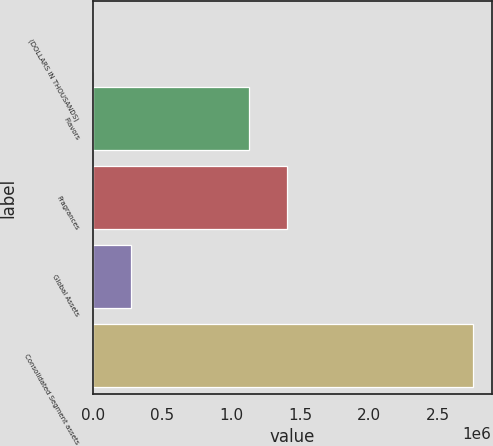Convert chart to OTSL. <chart><loc_0><loc_0><loc_500><loc_500><bar_chart><fcel>(DOLLARS IN THOUSANDS)<fcel>Flavors<fcel>Fragrances<fcel>Global Assets<fcel>Consolidated Segment assets<nl><fcel>2008<fcel>1.13178e+06<fcel>1.40657e+06<fcel>276798<fcel>2.74991e+06<nl></chart> 